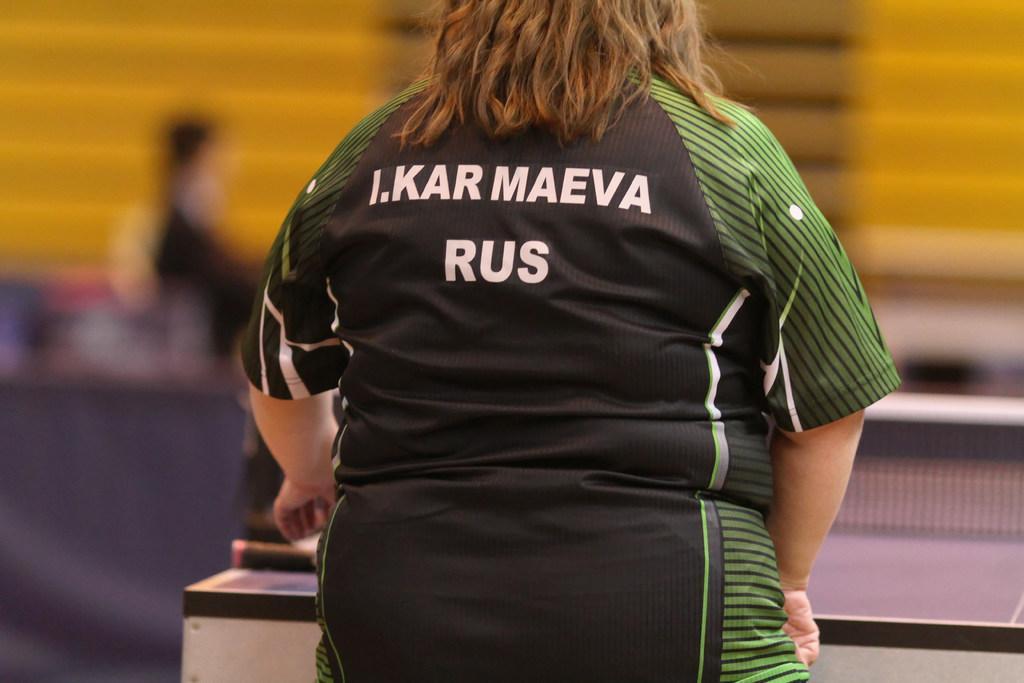How would you summarize this image in a sentence or two? In this image, we can see a woman standing, she is wearing a T-shirt. There is a blurred background. 